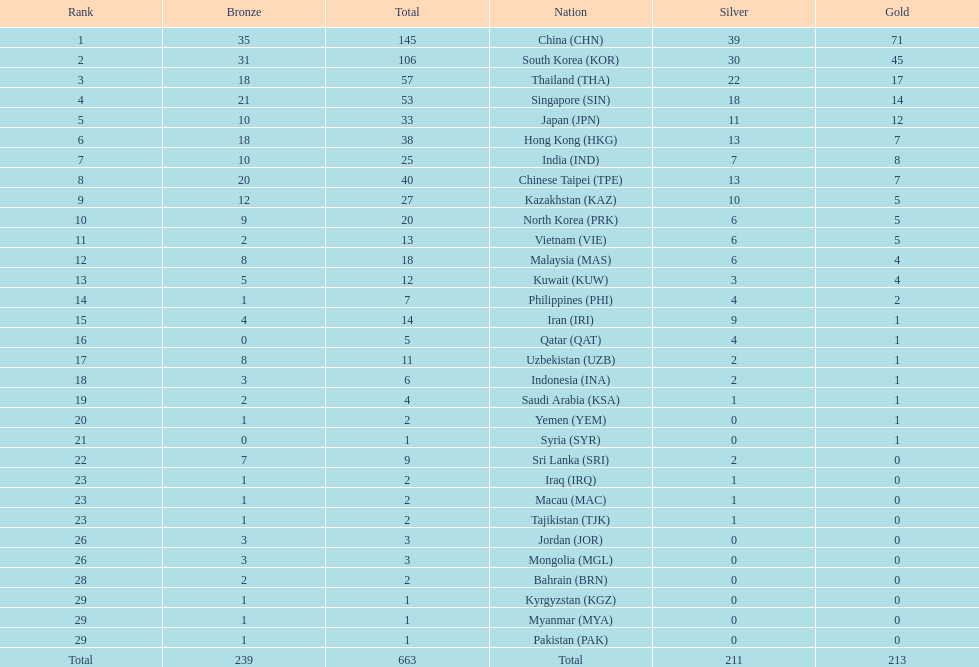Which countries have the same number of silver medals in the asian youth games as north korea? Vietnam (VIE), Malaysia (MAS). 